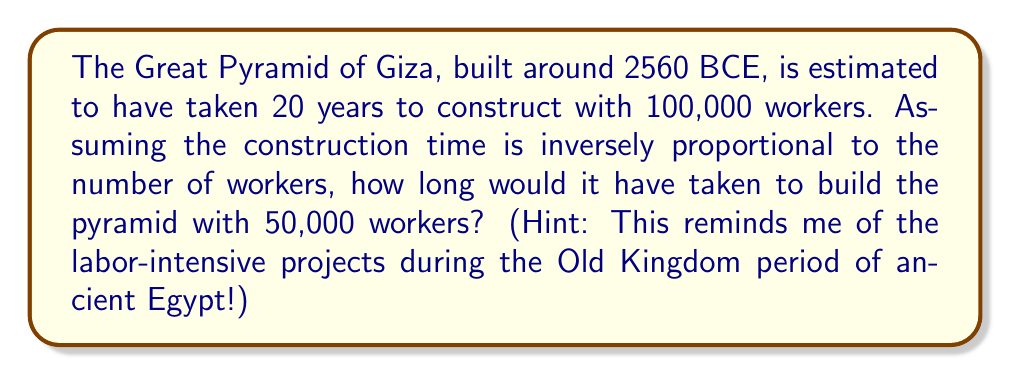Give your solution to this math problem. Let's approach this step-by-step using inverse proportional functions:

1) Let $t$ be the time (in years) and $w$ be the number of workers. The inverse proportional relationship can be expressed as:

   $t \propto \frac{1}{w}$ or $t = \frac{k}{w}$, where $k$ is a constant.

2) We know that when $w = 100,000$, $t = 20$. Let's use this to find $k$:

   $20 = \frac{k}{100,000}$
   $k = 20 \times 100,000 = 2,000,000$

3) Now we have our function: $t = \frac{2,000,000}{w}$

4) To find the time for 50,000 workers, we substitute $w = 50,000$:

   $t = \frac{2,000,000}{50,000} = 40$

Therefore, with 50,000 workers, it would have taken 40 years to build the Great Pyramid.

This inverse relationship reflects the idea that as the number of workers decreases, the time required increases proportionally, much like how the vast labor force of ancient Egypt was crucial for completing monumental projects in shorter timeframes.
Answer: 40 years 